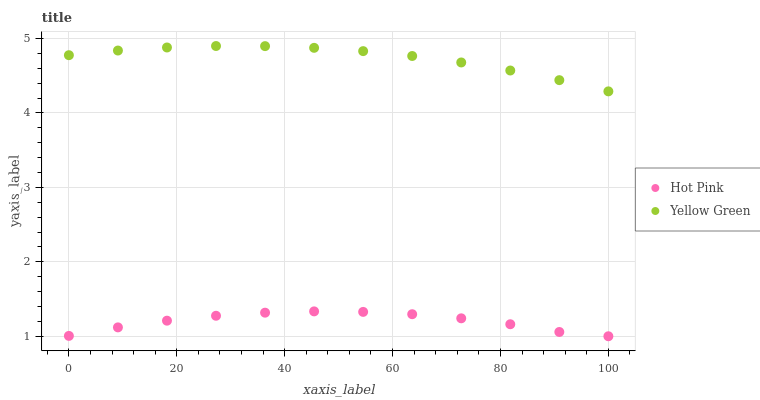Does Hot Pink have the minimum area under the curve?
Answer yes or no. Yes. Does Yellow Green have the maximum area under the curve?
Answer yes or no. Yes. Does Yellow Green have the minimum area under the curve?
Answer yes or no. No. Is Yellow Green the smoothest?
Answer yes or no. Yes. Is Hot Pink the roughest?
Answer yes or no. Yes. Is Yellow Green the roughest?
Answer yes or no. No. Does Hot Pink have the lowest value?
Answer yes or no. Yes. Does Yellow Green have the lowest value?
Answer yes or no. No. Does Yellow Green have the highest value?
Answer yes or no. Yes. Is Hot Pink less than Yellow Green?
Answer yes or no. Yes. Is Yellow Green greater than Hot Pink?
Answer yes or no. Yes. Does Hot Pink intersect Yellow Green?
Answer yes or no. No. 